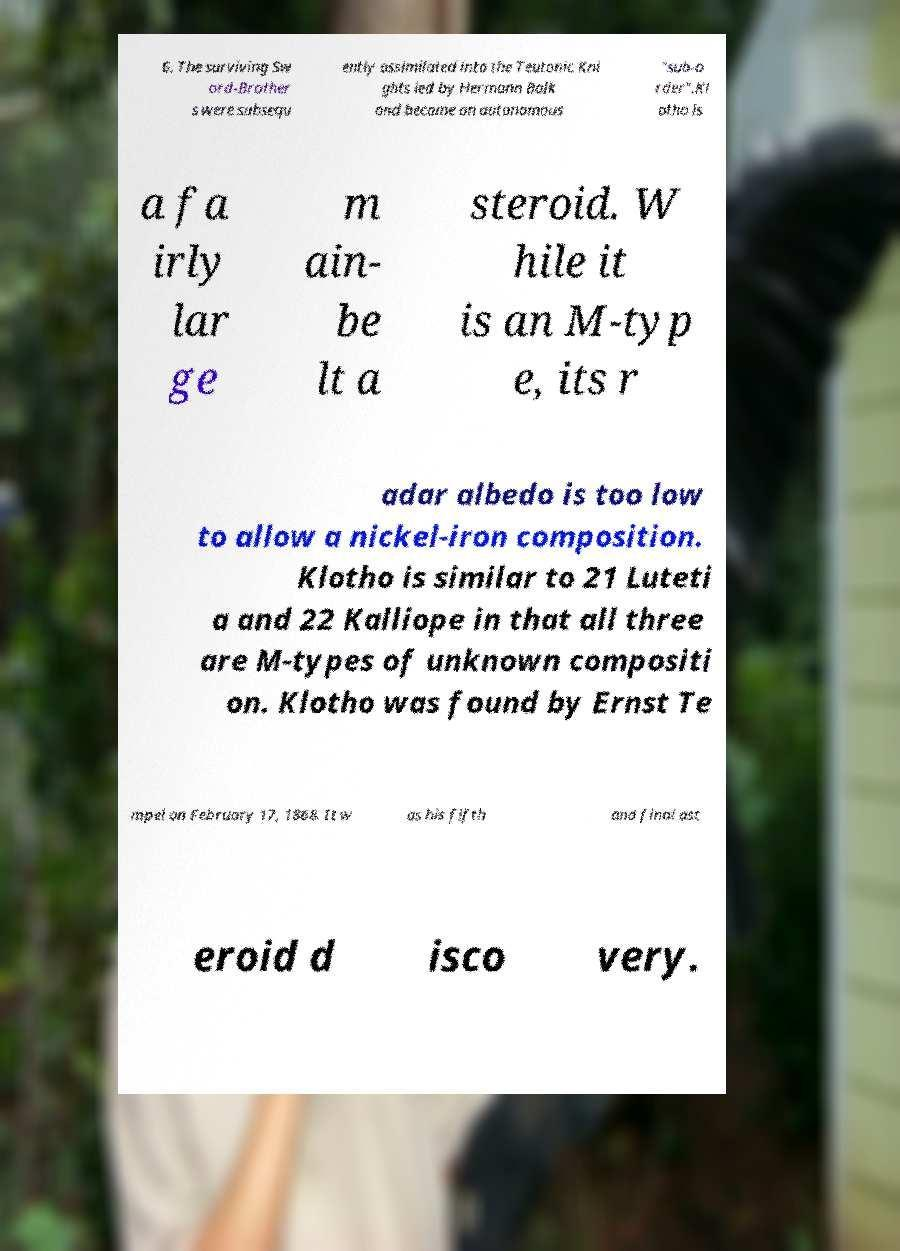Could you assist in decoding the text presented in this image and type it out clearly? 6. The surviving Sw ord-Brother s were subsequ ently assimilated into the Teutonic Kni ghts led by Hermann Balk and became an autonomous "sub-o rder".Kl otho is a fa irly lar ge m ain- be lt a steroid. W hile it is an M-typ e, its r adar albedo is too low to allow a nickel-iron composition. Klotho is similar to 21 Luteti a and 22 Kalliope in that all three are M-types of unknown compositi on. Klotho was found by Ernst Te mpel on February 17, 1868. It w as his fifth and final ast eroid d isco very. 